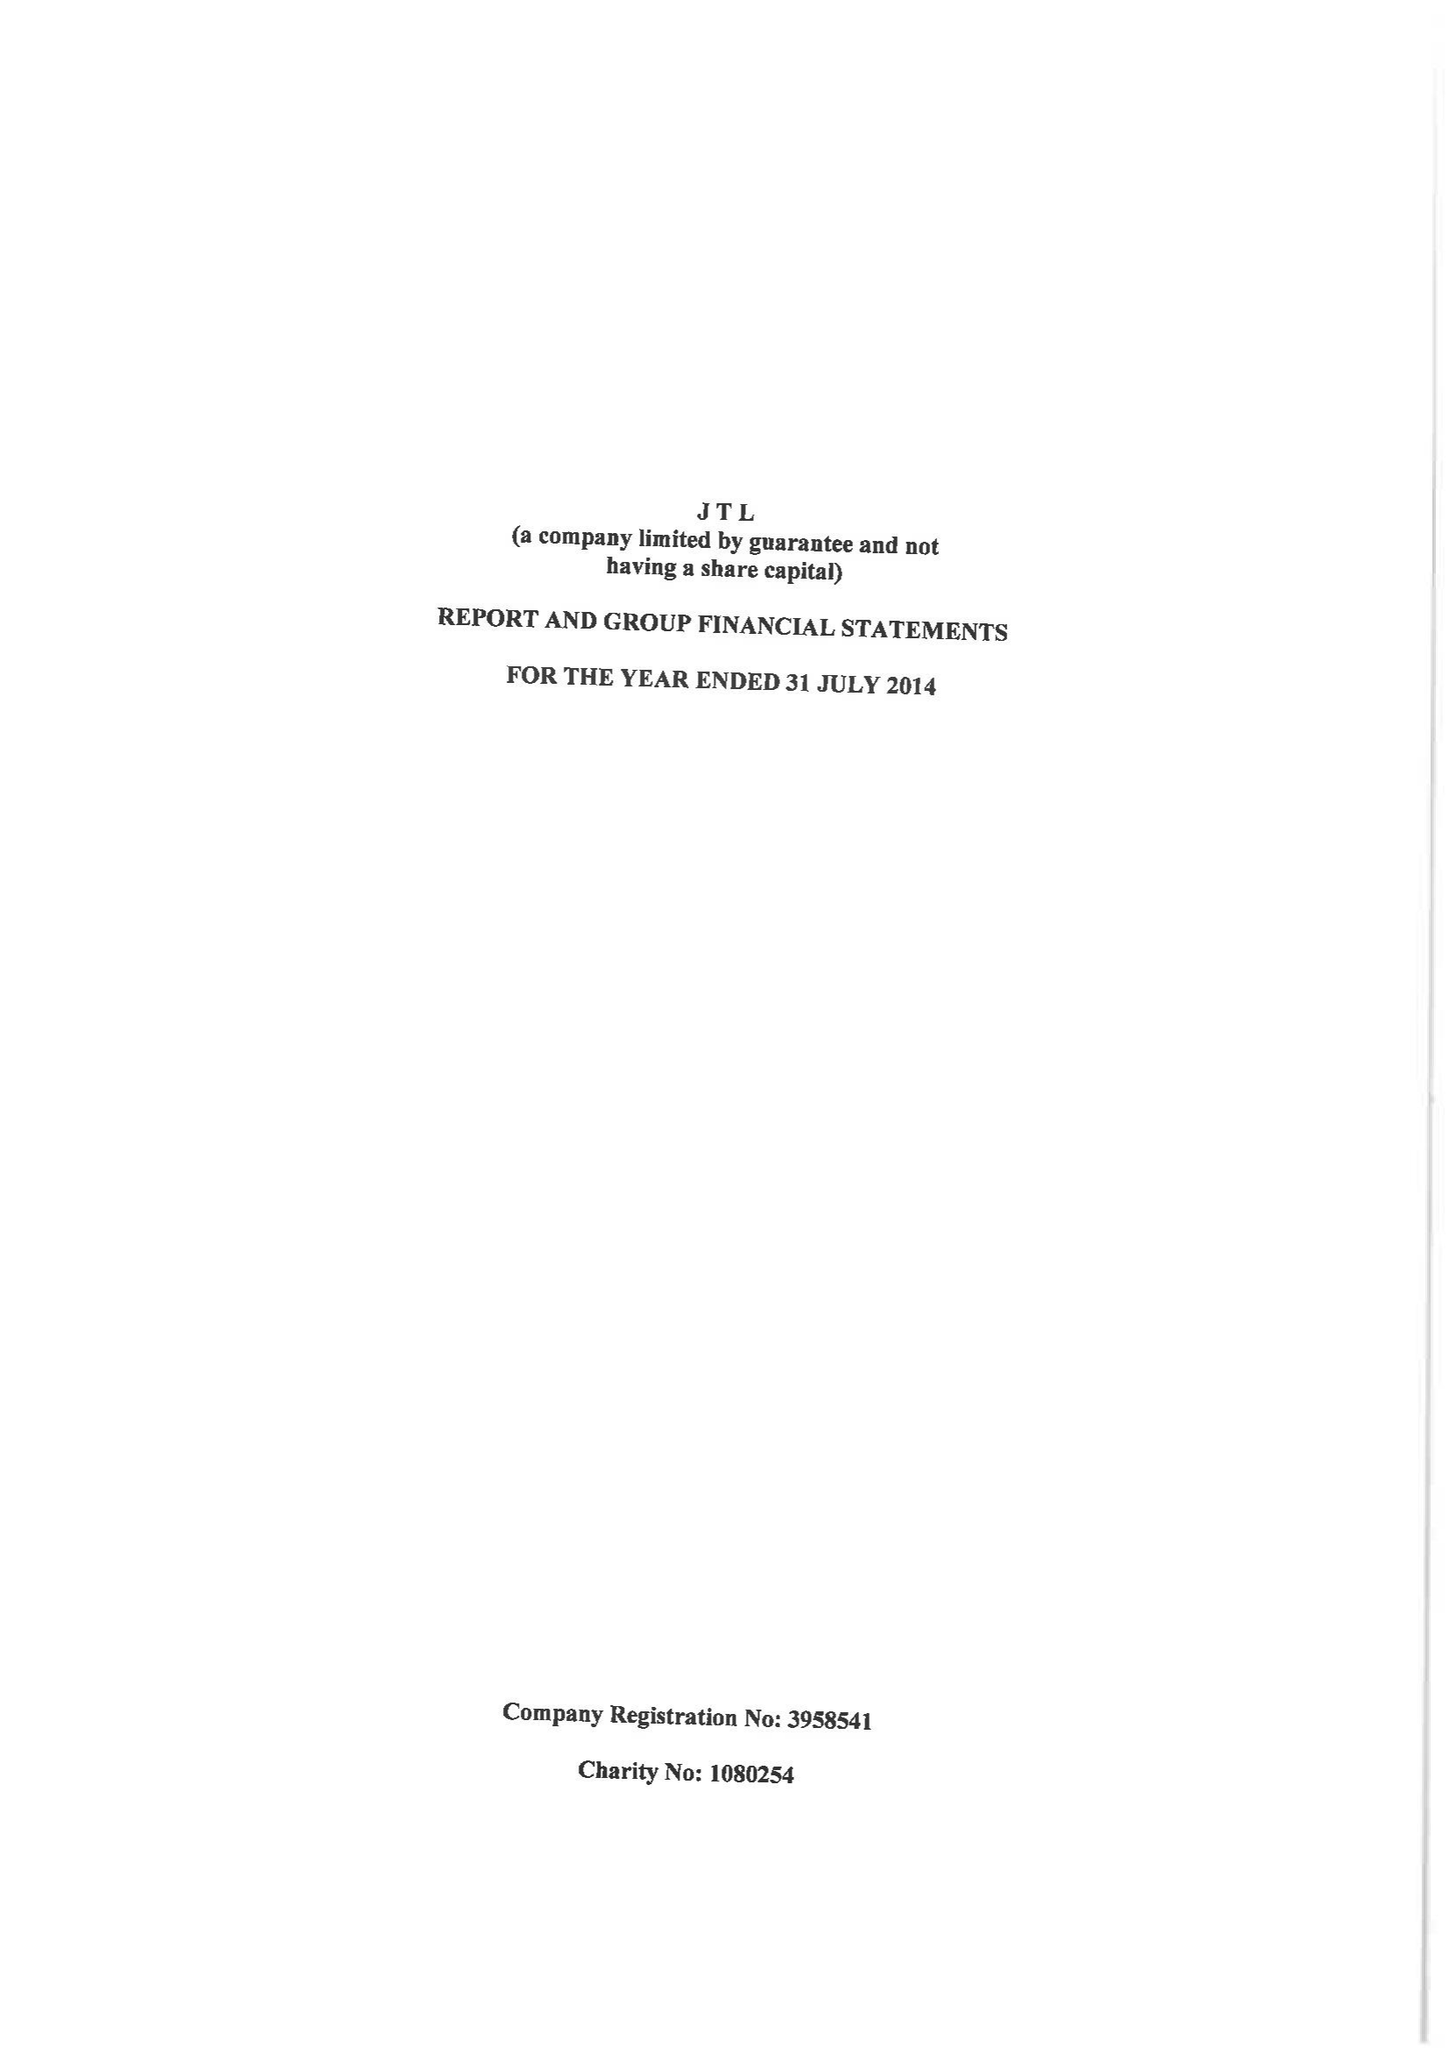What is the value for the address__postcode?
Answer the question using a single word or phrase. BR6 0JS 